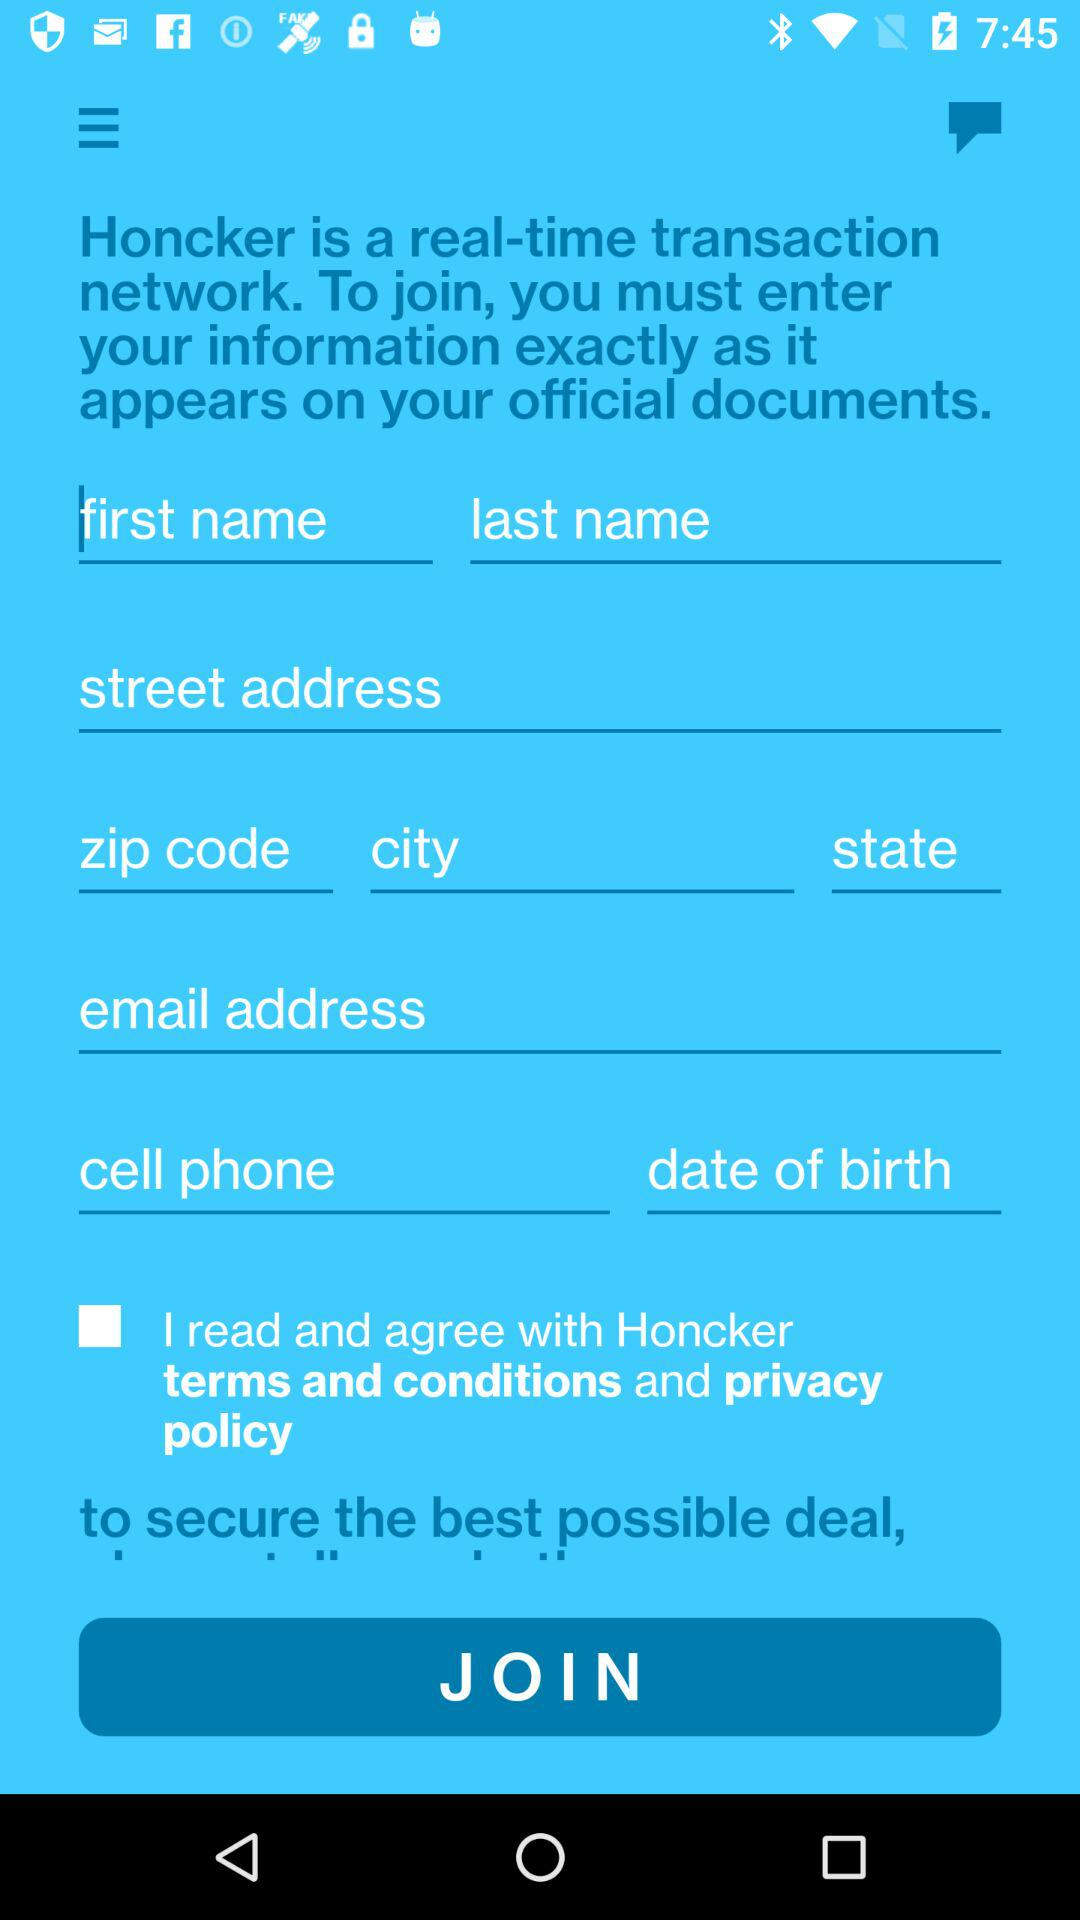How many text inputs are there that require the user to enter their name?
Answer the question using a single word or phrase. 2 